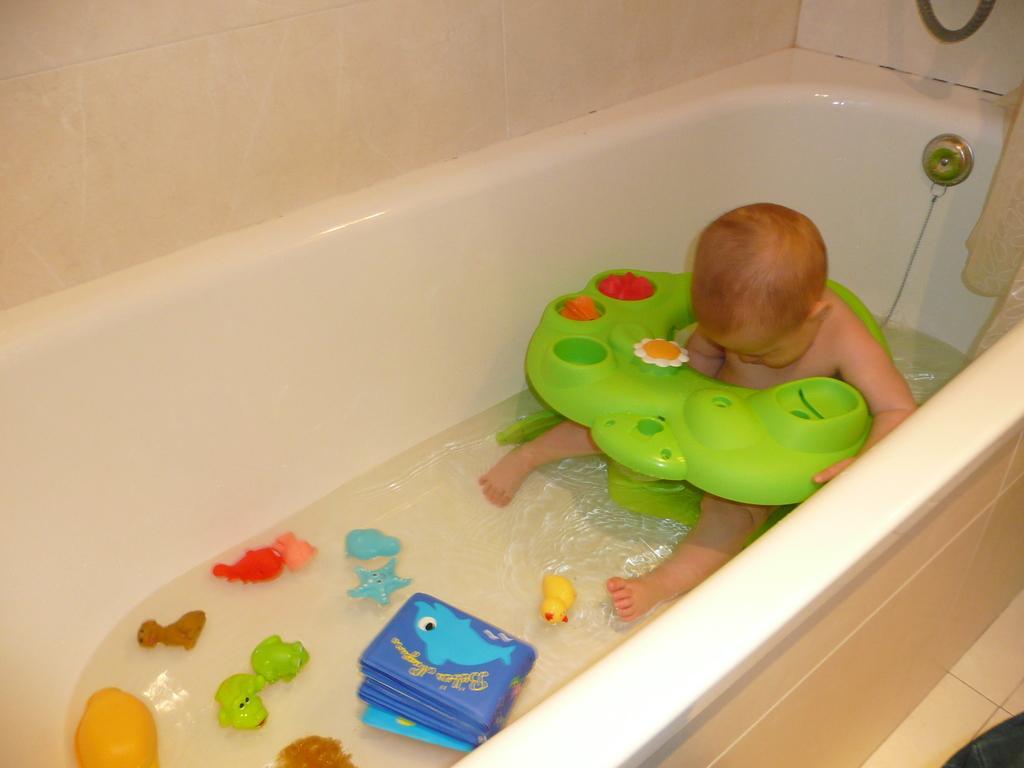In one or two sentences, can you explain what this image depicts? In this image I can see a child is in the bath tub which is white in color and in the bathtub I can see some water, few toys which are blue, red, yellow, green and brown in color. I can see the cream colored wall. 